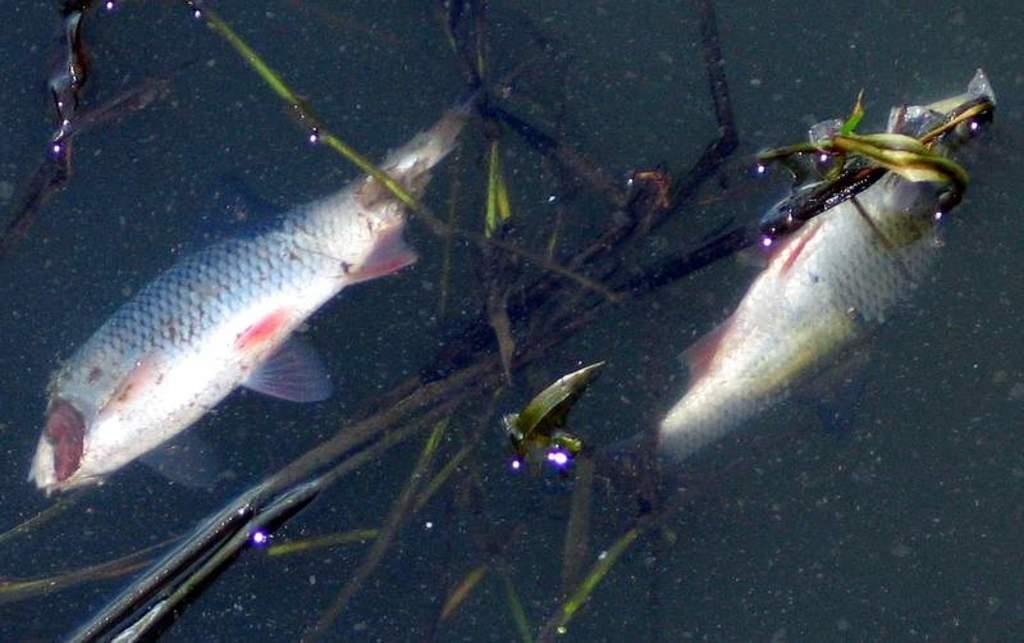Can you describe this image briefly? In this image I can see the water. I can see a plant and two fishes on the surface of the water. 